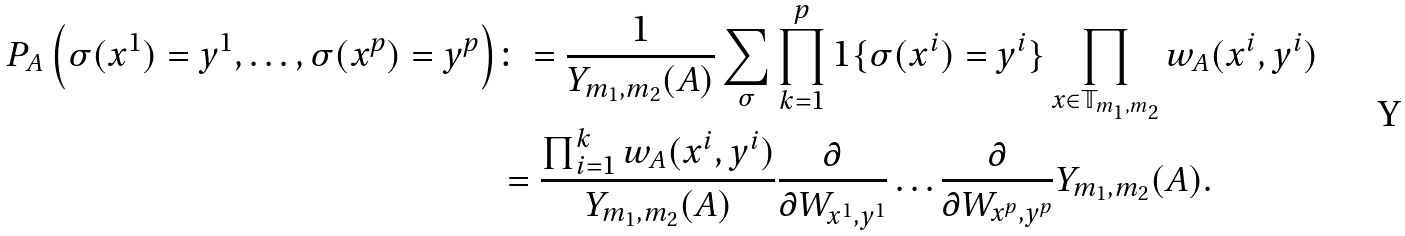<formula> <loc_0><loc_0><loc_500><loc_500>P _ { A } \left ( \sigma ( x ^ { 1 } ) = y ^ { 1 } , \dots , \sigma ( x ^ { p } ) = y ^ { p } \right ) & \colon = \frac { 1 } { Y _ { m _ { 1 } , m _ { 2 } } ( A ) } \sum _ { \sigma } \prod _ { k = 1 } ^ { p } 1 \{ \sigma ( x ^ { i } ) = y ^ { i } \} \prod _ { x \in \mathbb { T } _ { m _ { 1 } , m _ { 2 } } } w _ { A } ( x ^ { i } , y ^ { i } ) \\ & = \frac { \prod _ { i = 1 } ^ { k } w _ { A } ( x ^ { i } , y ^ { i } ) } { Y _ { m _ { 1 } , m _ { 2 } } ( A ) } \frac { \partial } { \partial W _ { x ^ { 1 } , y ^ { 1 } } } \dots \frac { \partial } { \partial W _ { x ^ { p } , y ^ { p } } } Y _ { m _ { 1 } , m _ { 2 } } ( A ) .</formula> 